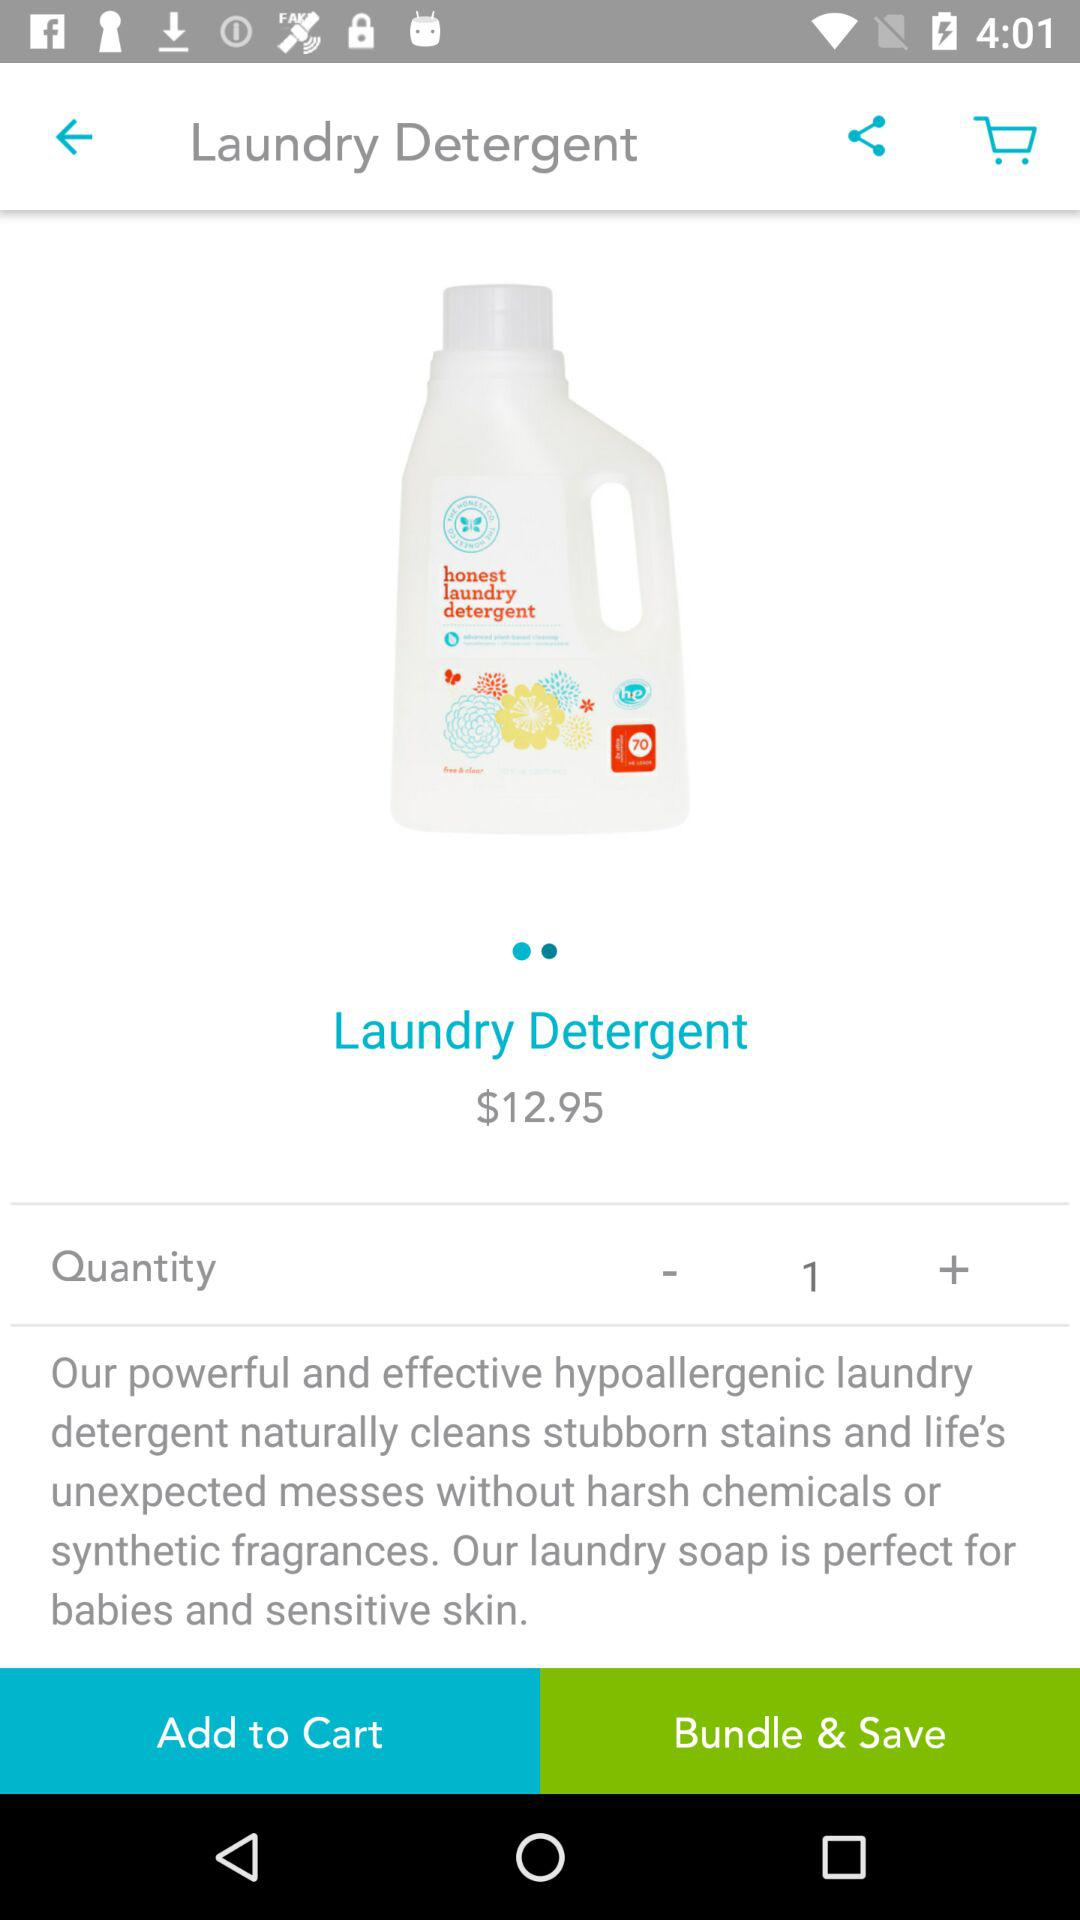What is the price of "Laundry Detergent"? The price is $12.95. 